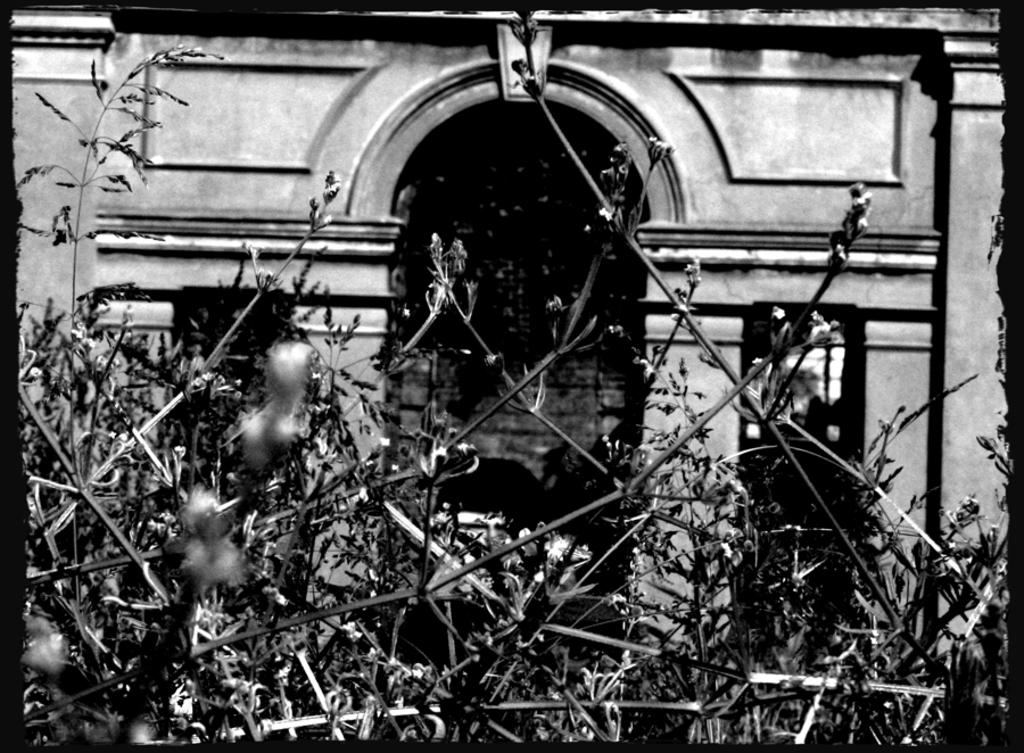What is the color scheme of the image? The image is black and white. What type of structure is visible in the image? There is a wall of a building in the image. Are there any specific features on the wall? Yes, there is an arch in the wall. What can be seen in the foreground of the image? There are plants in the foreground of the image. How many buckets are hanging from the arch in the image? There are no buckets present in the image; it only features a wall with an arch and plants in the foreground. What color is the silver object on the wall? There is no silver object present on the wall in the image. 